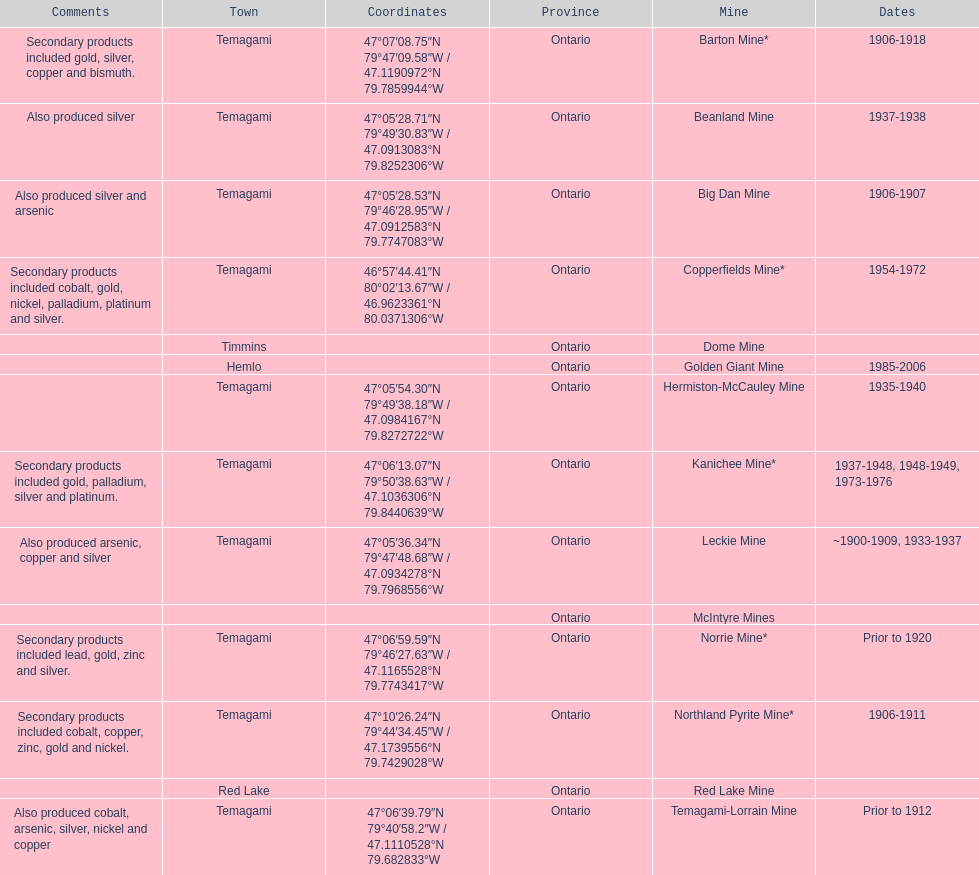Tell me the number of mines that also produced arsenic. 3. 